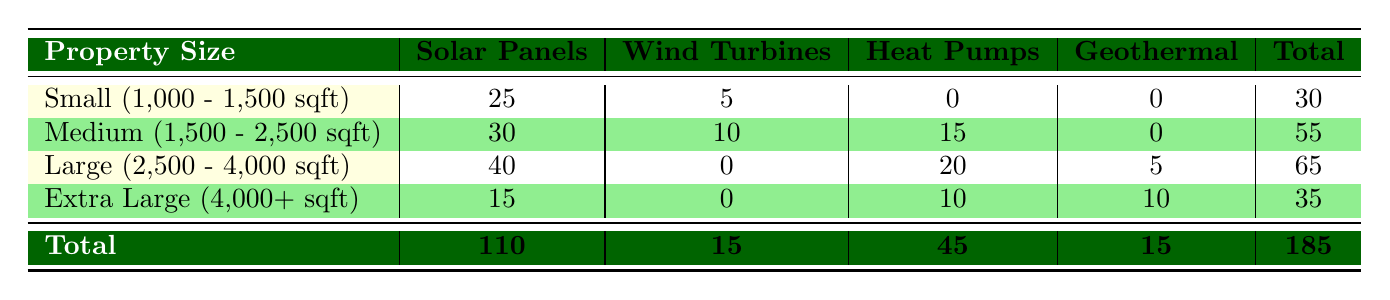What is the total number of preferred energy systems for small properties? The frequency for small properties is listed in the first row. The total for 'Solar Panels' is 25 and for 'Wind Turbines' is 5. Adding these gives 25 + 5 = 30.
Answer: 30 Which type of renewable energy system is most preferred by large property owners? For large properties, the highest frequency is associated with 'Solar Panels', which has a frequency of 40.
Answer: Solar Panels True or False: Medium-sized properties prefer Wind Turbines over Heat Pumps. Looking at the medium property row, 'Wind Turbines' has a frequency of 10 while 'Heat Pumps' has a frequency of 15. Since 10 is less than 15, the statement is false.
Answer: False What is the total number of preferred energy systems across all property sizes? To find the total, we need to sum all the frequencies from each row. The values for small (30), medium (55), large (65), and extra large (35) properties add up to 30 + 55 + 65 + 35 = 185.
Answer: 185 In which property size category do we see the highest preference for Heat Pumps? The frequencies for Heat Pumps are 0 (small), 15 (medium), 20 (large), and 10 (extra large). The largest is 20, which occurs in the large property category.
Answer: Large (2,500 - 4,000 sqft) How many more preferred energy systems do large properties have than extra large properties? First, find the total for large properties, which is 65, and the total for extra large properties, which is 35. The difference is 65 - 35 = 30.
Answer: 30 What is the frequency of Geothermal systems for small properties? In the small property row, the frequency for 'Geothermal' is listed as 0.
Answer: 0 Does the preference for Solar Panels decrease as property size increases? The frequencies for Solar Panels are 25 (small), 30 (medium), 40 (large), and 15 (extra large). Since the numbers increase until they peak at large properties, then decrease for extra large, the preference does decrease after reaching the large category.
Answer: Yes 